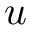Convert formula to latex. <formula><loc_0><loc_0><loc_500><loc_500>u</formula> 